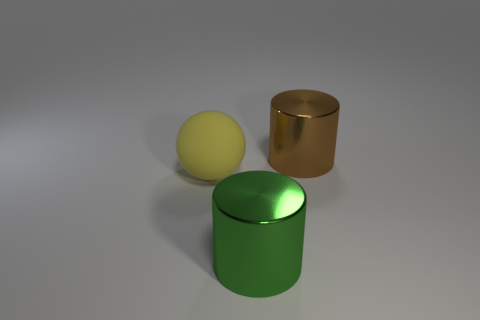Add 3 green cylinders. How many objects exist? 6 Subtract all cylinders. How many objects are left? 1 Add 2 large yellow matte spheres. How many large yellow matte spheres are left? 3 Add 2 large yellow things. How many large yellow things exist? 3 Subtract 0 gray blocks. How many objects are left? 3 Subtract all large spheres. Subtract all large rubber objects. How many objects are left? 1 